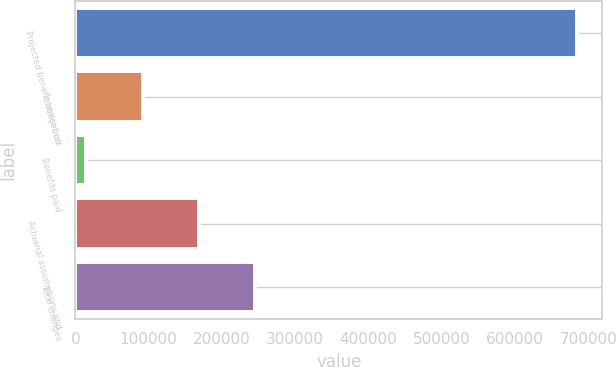Convert chart to OTSL. <chart><loc_0><loc_0><loc_500><loc_500><bar_chart><fcel>Projected benefit obligation<fcel>Interest cost<fcel>Benefits paid<fcel>Actuarial assumptions and<fcel>Total changes<nl><fcel>684999<fcel>91775.2<fcel>14886<fcel>168664<fcel>245554<nl></chart> 